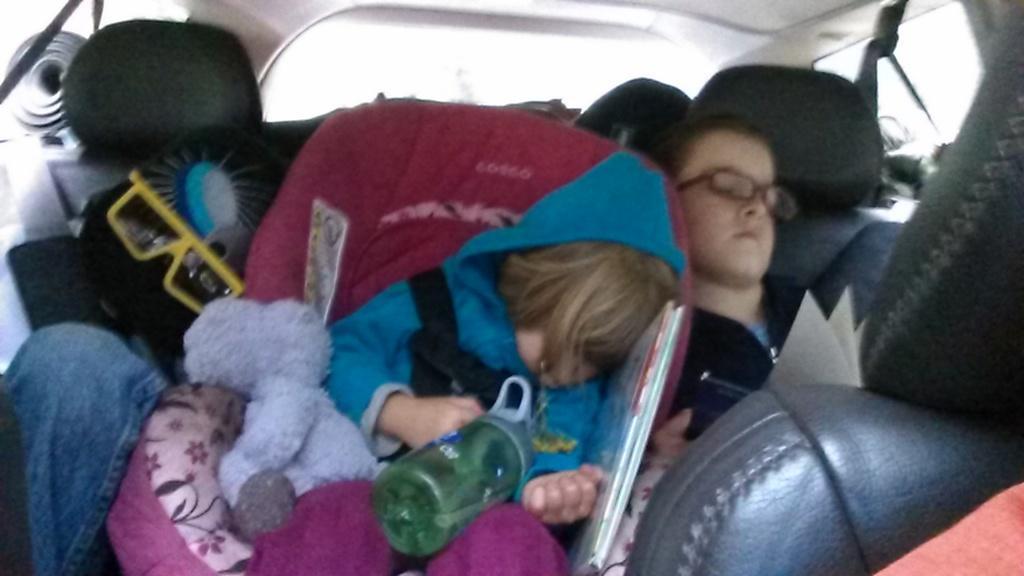Can you describe this image briefly? In this image we can see some people sitting inside a vehicle and we can see they are holding some objects in their hands. 